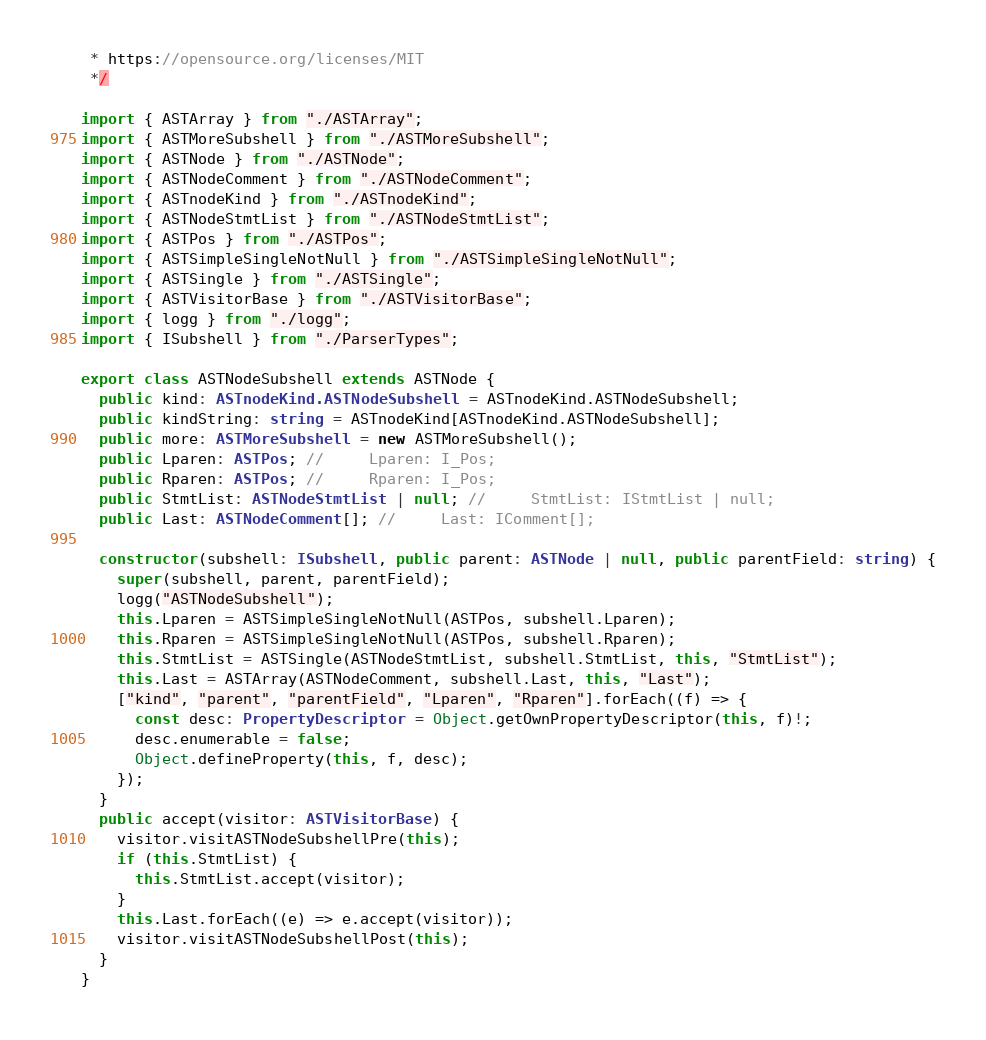Convert code to text. <code><loc_0><loc_0><loc_500><loc_500><_TypeScript_> * https://opensource.org/licenses/MIT
 */

import { ASTArray } from "./ASTArray";
import { ASTMoreSubshell } from "./ASTMoreSubshell";
import { ASTNode } from "./ASTNode";
import { ASTNodeComment } from "./ASTNodeComment";
import { ASTnodeKind } from "./ASTnodeKind";
import { ASTNodeStmtList } from "./ASTNodeStmtList";
import { ASTPos } from "./ASTPos";
import { ASTSimpleSingleNotNull } from "./ASTSimpleSingleNotNull";
import { ASTSingle } from "./ASTSingle";
import { ASTVisitorBase } from "./ASTVisitorBase";
import { logg } from "./logg";
import { ISubshell } from "./ParserTypes";

export class ASTNodeSubshell extends ASTNode {
  public kind: ASTnodeKind.ASTNodeSubshell = ASTnodeKind.ASTNodeSubshell;
  public kindString: string = ASTnodeKind[ASTnodeKind.ASTNodeSubshell];
  public more: ASTMoreSubshell = new ASTMoreSubshell();
  public Lparen: ASTPos; //     Lparen: I_Pos;
  public Rparen: ASTPos; //     Rparen: I_Pos;
  public StmtList: ASTNodeStmtList | null; //     StmtList: IStmtList | null;
  public Last: ASTNodeComment[]; //     Last: IComment[];

  constructor(subshell: ISubshell, public parent: ASTNode | null, public parentField: string) {
    super(subshell, parent, parentField);
    logg("ASTNodeSubshell");
    this.Lparen = ASTSimpleSingleNotNull(ASTPos, subshell.Lparen);
    this.Rparen = ASTSimpleSingleNotNull(ASTPos, subshell.Rparen);
    this.StmtList = ASTSingle(ASTNodeStmtList, subshell.StmtList, this, "StmtList");
    this.Last = ASTArray(ASTNodeComment, subshell.Last, this, "Last");
    ["kind", "parent", "parentField", "Lparen", "Rparen"].forEach((f) => {
      const desc: PropertyDescriptor = Object.getOwnPropertyDescriptor(this, f)!;
      desc.enumerable = false;
      Object.defineProperty(this, f, desc);
    });
  }
  public accept(visitor: ASTVisitorBase) {
    visitor.visitASTNodeSubshellPre(this);
    if (this.StmtList) {
      this.StmtList.accept(visitor);
    }
    this.Last.forEach((e) => e.accept(visitor));
    visitor.visitASTNodeSubshellPost(this);
  }
}
</code> 